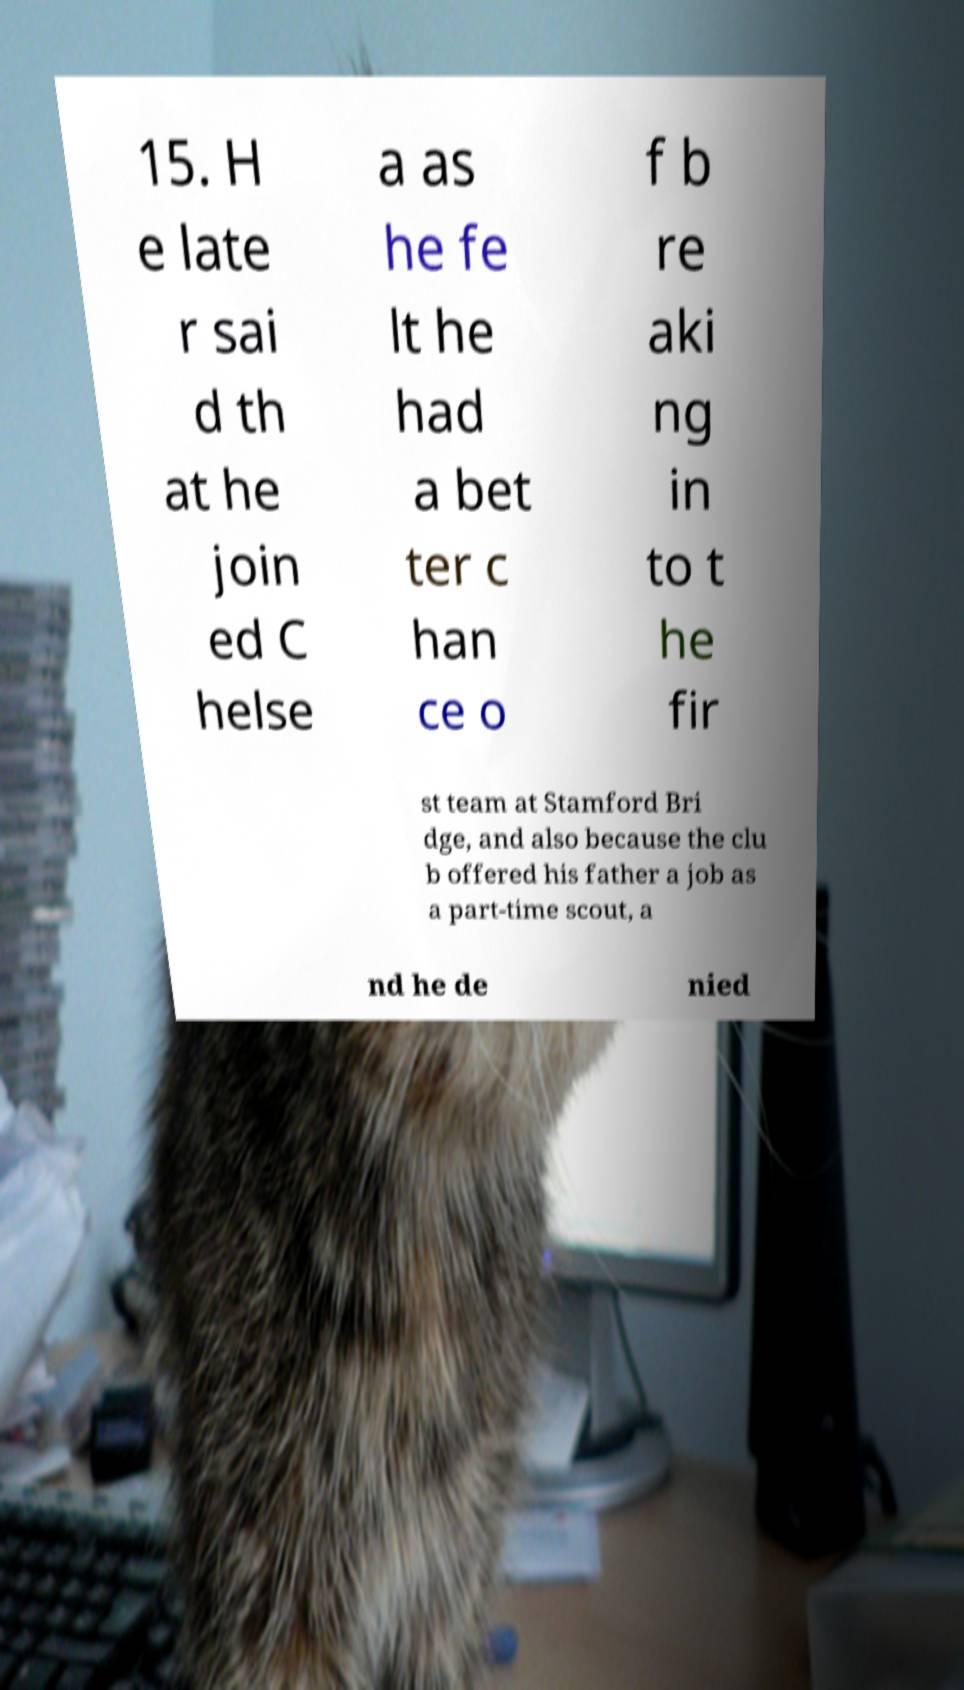There's text embedded in this image that I need extracted. Can you transcribe it verbatim? 15. H e late r sai d th at he join ed C helse a as he fe lt he had a bet ter c han ce o f b re aki ng in to t he fir st team at Stamford Bri dge, and also because the clu b offered his father a job as a part-time scout, a nd he de nied 